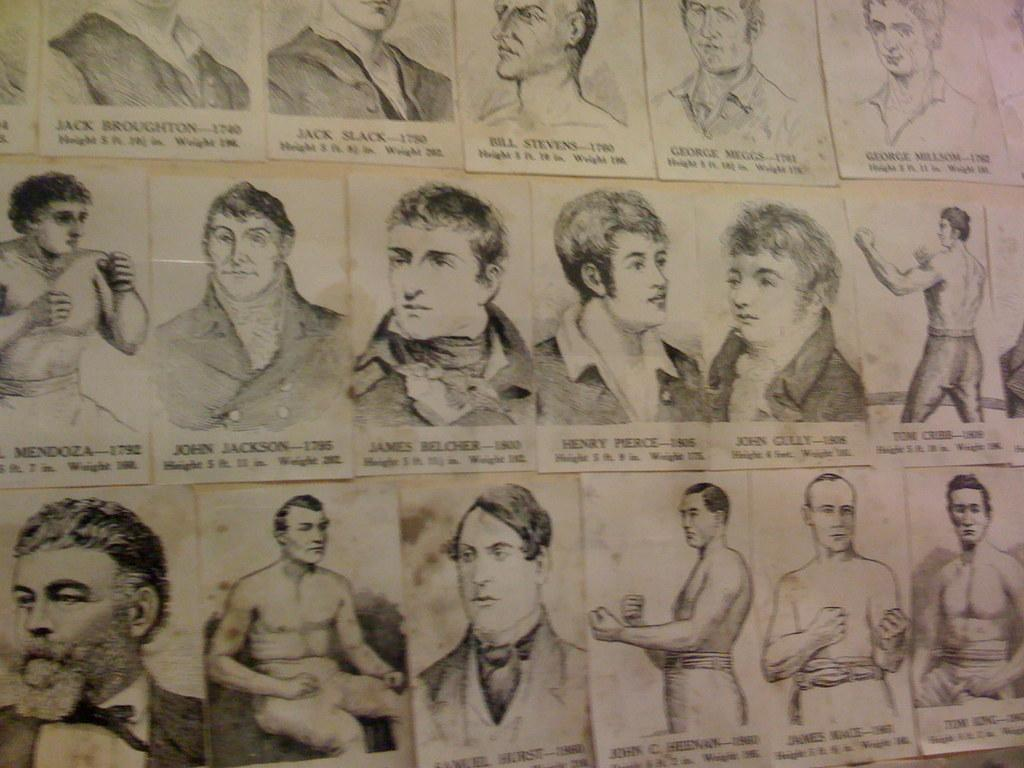What is present in the image that contains visual information? There is a paper in the image that contains pictures of people. What type of content is included on the paper? The paper contains pictures of people and writing under the pictures. Where can the monkey be seen playing with a bun in the image? There is no monkey or bun present in the image. 